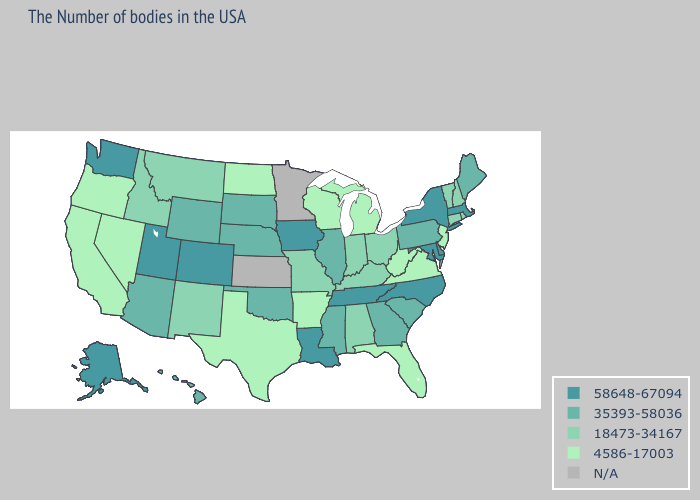Which states have the highest value in the USA?
Be succinct. Massachusetts, New York, Delaware, Maryland, North Carolina, Tennessee, Louisiana, Iowa, Colorado, Utah, Washington, Alaska. Name the states that have a value in the range 58648-67094?
Give a very brief answer. Massachusetts, New York, Delaware, Maryland, North Carolina, Tennessee, Louisiana, Iowa, Colorado, Utah, Washington, Alaska. Among the states that border Montana , does Wyoming have the lowest value?
Be succinct. No. Does the map have missing data?
Be succinct. Yes. What is the value of Wyoming?
Short answer required. 35393-58036. What is the highest value in the USA?
Give a very brief answer. 58648-67094. What is the lowest value in the USA?
Quick response, please. 4586-17003. What is the value of Connecticut?
Give a very brief answer. 18473-34167. Name the states that have a value in the range 58648-67094?
Give a very brief answer. Massachusetts, New York, Delaware, Maryland, North Carolina, Tennessee, Louisiana, Iowa, Colorado, Utah, Washington, Alaska. Name the states that have a value in the range 35393-58036?
Give a very brief answer. Maine, Pennsylvania, South Carolina, Georgia, Illinois, Mississippi, Nebraska, Oklahoma, South Dakota, Wyoming, Arizona, Hawaii. What is the value of Connecticut?
Concise answer only. 18473-34167. What is the value of Louisiana?
Give a very brief answer. 58648-67094. What is the value of California?
Concise answer only. 4586-17003. Does Nevada have the lowest value in the West?
Give a very brief answer. Yes. How many symbols are there in the legend?
Answer briefly. 5. 